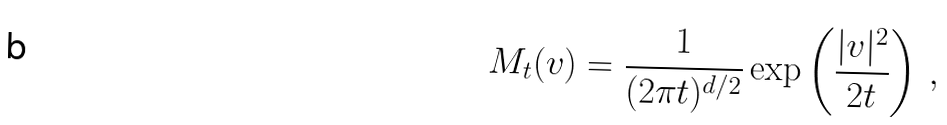<formula> <loc_0><loc_0><loc_500><loc_500>M _ { t } ( v ) = \frac { 1 } { ( 2 \pi t ) ^ { d / 2 } } \exp \left ( \frac { | v | ^ { 2 } } { 2 t } \right ) \, ,</formula> 